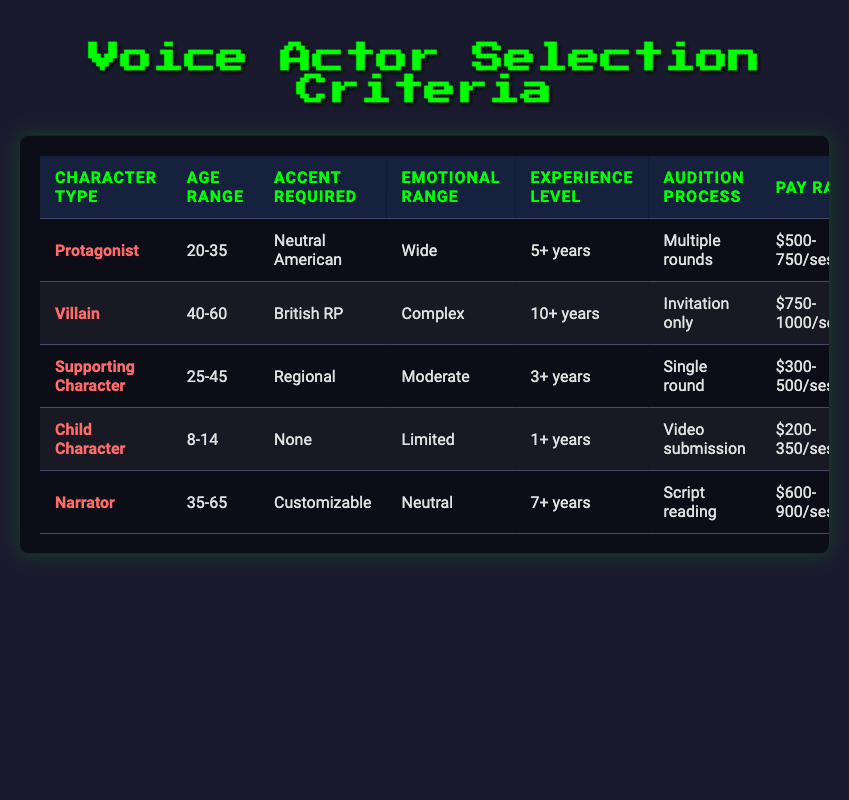What is the pay rate for a supporting character? The pay rate for a supporting character is listed in the table under the corresponding row, which shows it as $300-500/session.
Answer: $300-500/session How many recording sessions are required for a villain? The table indicates that for a villain, the number of recording sessions is between 8-12 sessions as specified in the relevant row.
Answer: 8-12 Is the audition process for child characters a video submission? The table states that the audition process for child characters is indeed listed as 'Video submission', confirming that this is true.
Answer: Yes What character type requires the most experience level? By examining the experience levels for all character types in the table, it can be seen that the villain type requires the most experience at 10+ years, as mentioned in its row.
Answer: Villain What is the average number of sessions for a protagonist and narrator? The number of sessions for a protagonist is between 10-15, and for a narrator, it is between 2-4. To find the average, calculate the midpoints: (10+15)/2 = 12.5 for the protagonist and (2+4)/2 = 3 for the narrator. The total number of sessions is 12.5 + 3 = 15.5, and the average is then 15.5 / 2 = 7.75.
Answer: 7.75 Do all character types have an accent requirement? In the table, the child character does not have an accent requirement as it states 'None'. Therefore, not all character types have an accent requirement.
Answer: No What is the contract duration for the supporting character? Looking at the relevant row in the table, the contract duration for a supporting character is stated as 1 month.
Answer: 1 month Which character type requires the widest emotional range? The table shows that the protagonist has a 'Wide' emotional range, as indicated in the corresponding row, making it the character type with the widest emotional range.
Answer: Protagonist What is the difference in pay rate between the villain and child character? The villain's pay rate is between $750-1000, while the child character's pay rate is between $200-350. Calculating the range difference: (750 - 200) = 550 (lower end), and (1000 - 350) = 650 (upper end). Thus, the difference in pay rates ranges from 550 to 650.
Answer: 550-650 